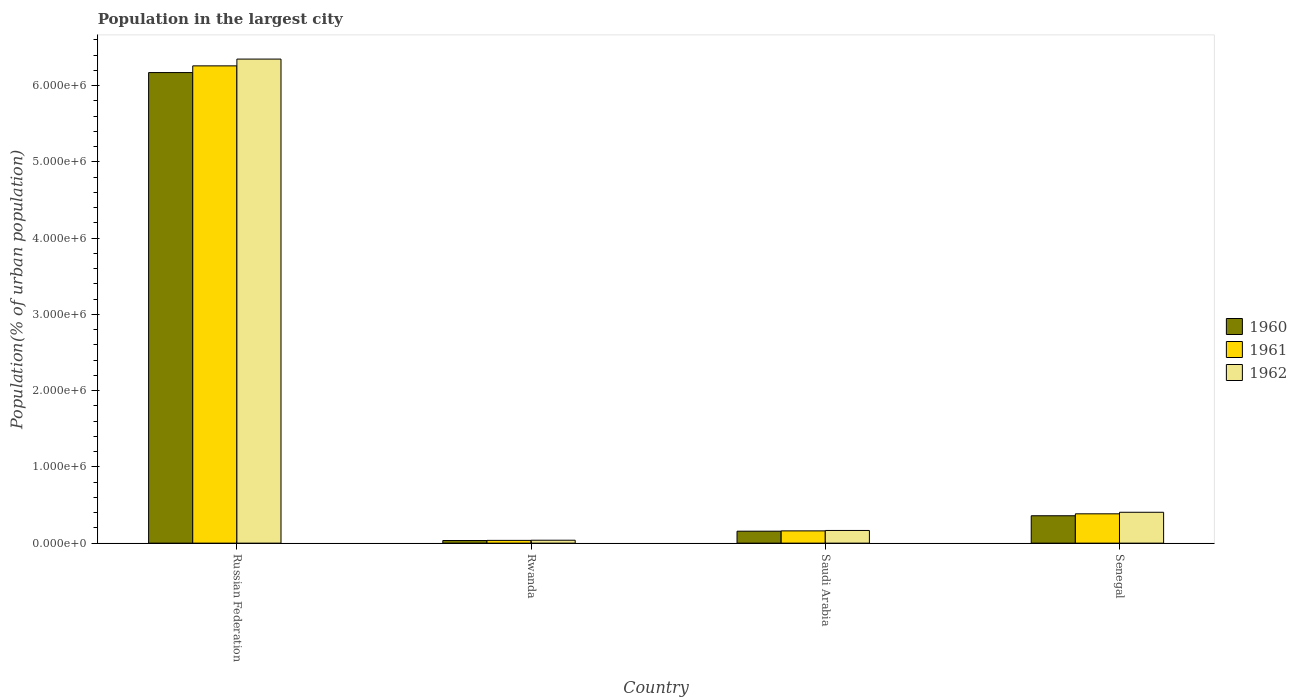How many groups of bars are there?
Offer a very short reply. 4. Are the number of bars per tick equal to the number of legend labels?
Give a very brief answer. Yes. What is the label of the 2nd group of bars from the left?
Keep it short and to the point. Rwanda. In how many cases, is the number of bars for a given country not equal to the number of legend labels?
Provide a short and direct response. 0. What is the population in the largest city in 1962 in Senegal?
Ensure brevity in your answer.  4.05e+05. Across all countries, what is the maximum population in the largest city in 1962?
Offer a very short reply. 6.35e+06. Across all countries, what is the minimum population in the largest city in 1960?
Provide a succinct answer. 3.43e+04. In which country was the population in the largest city in 1962 maximum?
Make the answer very short. Russian Federation. In which country was the population in the largest city in 1961 minimum?
Provide a succinct answer. Rwanda. What is the total population in the largest city in 1962 in the graph?
Provide a succinct answer. 6.96e+06. What is the difference between the population in the largest city in 1962 in Russian Federation and that in Senegal?
Offer a terse response. 5.94e+06. What is the difference between the population in the largest city in 1960 in Russian Federation and the population in the largest city in 1962 in Senegal?
Your answer should be very brief. 5.77e+06. What is the average population in the largest city in 1961 per country?
Give a very brief answer. 1.71e+06. What is the difference between the population in the largest city of/in 1960 and population in the largest city of/in 1962 in Russian Federation?
Keep it short and to the point. -1.77e+05. What is the ratio of the population in the largest city in 1961 in Saudi Arabia to that in Senegal?
Give a very brief answer. 0.42. Is the difference between the population in the largest city in 1960 in Rwanda and Senegal greater than the difference between the population in the largest city in 1962 in Rwanda and Senegal?
Provide a succinct answer. Yes. What is the difference between the highest and the second highest population in the largest city in 1962?
Provide a succinct answer. 5.94e+06. What is the difference between the highest and the lowest population in the largest city in 1961?
Offer a very short reply. 6.22e+06. What does the 1st bar from the left in Russian Federation represents?
Keep it short and to the point. 1960. Are all the bars in the graph horizontal?
Your response must be concise. No. What is the difference between two consecutive major ticks on the Y-axis?
Your answer should be compact. 1.00e+06. Does the graph contain any zero values?
Offer a very short reply. No. Does the graph contain grids?
Your answer should be compact. No. How many legend labels are there?
Make the answer very short. 3. What is the title of the graph?
Your answer should be very brief. Population in the largest city. Does "1978" appear as one of the legend labels in the graph?
Offer a very short reply. No. What is the label or title of the X-axis?
Provide a short and direct response. Country. What is the label or title of the Y-axis?
Provide a short and direct response. Population(% of urban population). What is the Population(% of urban population) of 1960 in Russian Federation?
Provide a succinct answer. 6.17e+06. What is the Population(% of urban population) of 1961 in Russian Federation?
Keep it short and to the point. 6.26e+06. What is the Population(% of urban population) of 1962 in Russian Federation?
Provide a short and direct response. 6.35e+06. What is the Population(% of urban population) in 1960 in Rwanda?
Ensure brevity in your answer.  3.43e+04. What is the Population(% of urban population) of 1961 in Rwanda?
Ensure brevity in your answer.  3.63e+04. What is the Population(% of urban population) in 1962 in Rwanda?
Keep it short and to the point. 3.83e+04. What is the Population(% of urban population) in 1960 in Saudi Arabia?
Make the answer very short. 1.57e+05. What is the Population(% of urban population) of 1961 in Saudi Arabia?
Provide a short and direct response. 1.61e+05. What is the Population(% of urban population) in 1962 in Saudi Arabia?
Offer a very short reply. 1.66e+05. What is the Population(% of urban population) in 1960 in Senegal?
Your answer should be very brief. 3.59e+05. What is the Population(% of urban population) in 1961 in Senegal?
Make the answer very short. 3.84e+05. What is the Population(% of urban population) of 1962 in Senegal?
Your response must be concise. 4.05e+05. Across all countries, what is the maximum Population(% of urban population) in 1960?
Provide a short and direct response. 6.17e+06. Across all countries, what is the maximum Population(% of urban population) in 1961?
Ensure brevity in your answer.  6.26e+06. Across all countries, what is the maximum Population(% of urban population) in 1962?
Your response must be concise. 6.35e+06. Across all countries, what is the minimum Population(% of urban population) in 1960?
Ensure brevity in your answer.  3.43e+04. Across all countries, what is the minimum Population(% of urban population) in 1961?
Provide a short and direct response. 3.63e+04. Across all countries, what is the minimum Population(% of urban population) in 1962?
Your answer should be compact. 3.83e+04. What is the total Population(% of urban population) of 1960 in the graph?
Keep it short and to the point. 6.72e+06. What is the total Population(% of urban population) of 1961 in the graph?
Offer a terse response. 6.84e+06. What is the total Population(% of urban population) in 1962 in the graph?
Provide a succinct answer. 6.96e+06. What is the difference between the Population(% of urban population) in 1960 in Russian Federation and that in Rwanda?
Offer a terse response. 6.14e+06. What is the difference between the Population(% of urban population) in 1961 in Russian Federation and that in Rwanda?
Give a very brief answer. 6.22e+06. What is the difference between the Population(% of urban population) of 1962 in Russian Federation and that in Rwanda?
Your answer should be very brief. 6.31e+06. What is the difference between the Population(% of urban population) of 1960 in Russian Federation and that in Saudi Arabia?
Your answer should be very brief. 6.01e+06. What is the difference between the Population(% of urban population) of 1961 in Russian Federation and that in Saudi Arabia?
Your answer should be compact. 6.10e+06. What is the difference between the Population(% of urban population) in 1962 in Russian Federation and that in Saudi Arabia?
Provide a short and direct response. 6.18e+06. What is the difference between the Population(% of urban population) in 1960 in Russian Federation and that in Senegal?
Offer a terse response. 5.81e+06. What is the difference between the Population(% of urban population) in 1961 in Russian Federation and that in Senegal?
Provide a succinct answer. 5.87e+06. What is the difference between the Population(% of urban population) in 1962 in Russian Federation and that in Senegal?
Your answer should be very brief. 5.94e+06. What is the difference between the Population(% of urban population) in 1960 in Rwanda and that in Saudi Arabia?
Ensure brevity in your answer.  -1.22e+05. What is the difference between the Population(% of urban population) in 1961 in Rwanda and that in Saudi Arabia?
Make the answer very short. -1.25e+05. What is the difference between the Population(% of urban population) of 1962 in Rwanda and that in Saudi Arabia?
Provide a short and direct response. -1.28e+05. What is the difference between the Population(% of urban population) of 1960 in Rwanda and that in Senegal?
Offer a very short reply. -3.25e+05. What is the difference between the Population(% of urban population) in 1961 in Rwanda and that in Senegal?
Ensure brevity in your answer.  -3.48e+05. What is the difference between the Population(% of urban population) of 1962 in Rwanda and that in Senegal?
Make the answer very short. -3.66e+05. What is the difference between the Population(% of urban population) in 1960 in Saudi Arabia and that in Senegal?
Provide a short and direct response. -2.02e+05. What is the difference between the Population(% of urban population) of 1961 in Saudi Arabia and that in Senegal?
Offer a terse response. -2.24e+05. What is the difference between the Population(% of urban population) in 1962 in Saudi Arabia and that in Senegal?
Offer a terse response. -2.38e+05. What is the difference between the Population(% of urban population) in 1960 in Russian Federation and the Population(% of urban population) in 1961 in Rwanda?
Make the answer very short. 6.13e+06. What is the difference between the Population(% of urban population) in 1960 in Russian Federation and the Population(% of urban population) in 1962 in Rwanda?
Your answer should be very brief. 6.13e+06. What is the difference between the Population(% of urban population) in 1961 in Russian Federation and the Population(% of urban population) in 1962 in Rwanda?
Provide a short and direct response. 6.22e+06. What is the difference between the Population(% of urban population) of 1960 in Russian Federation and the Population(% of urban population) of 1961 in Saudi Arabia?
Provide a short and direct response. 6.01e+06. What is the difference between the Population(% of urban population) in 1960 in Russian Federation and the Population(% of urban population) in 1962 in Saudi Arabia?
Keep it short and to the point. 6.00e+06. What is the difference between the Population(% of urban population) in 1961 in Russian Federation and the Population(% of urban population) in 1962 in Saudi Arabia?
Your answer should be very brief. 6.09e+06. What is the difference between the Population(% of urban population) in 1960 in Russian Federation and the Population(% of urban population) in 1961 in Senegal?
Your response must be concise. 5.79e+06. What is the difference between the Population(% of urban population) of 1960 in Russian Federation and the Population(% of urban population) of 1962 in Senegal?
Offer a very short reply. 5.77e+06. What is the difference between the Population(% of urban population) of 1961 in Russian Federation and the Population(% of urban population) of 1962 in Senegal?
Make the answer very short. 5.85e+06. What is the difference between the Population(% of urban population) in 1960 in Rwanda and the Population(% of urban population) in 1961 in Saudi Arabia?
Keep it short and to the point. -1.27e+05. What is the difference between the Population(% of urban population) of 1960 in Rwanda and the Population(% of urban population) of 1962 in Saudi Arabia?
Your answer should be compact. -1.32e+05. What is the difference between the Population(% of urban population) in 1961 in Rwanda and the Population(% of urban population) in 1962 in Saudi Arabia?
Provide a succinct answer. -1.30e+05. What is the difference between the Population(% of urban population) in 1960 in Rwanda and the Population(% of urban population) in 1961 in Senegal?
Keep it short and to the point. -3.50e+05. What is the difference between the Population(% of urban population) in 1960 in Rwanda and the Population(% of urban population) in 1962 in Senegal?
Your response must be concise. -3.70e+05. What is the difference between the Population(% of urban population) of 1961 in Rwanda and the Population(% of urban population) of 1962 in Senegal?
Keep it short and to the point. -3.69e+05. What is the difference between the Population(% of urban population) of 1960 in Saudi Arabia and the Population(% of urban population) of 1961 in Senegal?
Provide a succinct answer. -2.28e+05. What is the difference between the Population(% of urban population) of 1960 in Saudi Arabia and the Population(% of urban population) of 1962 in Senegal?
Give a very brief answer. -2.48e+05. What is the difference between the Population(% of urban population) in 1961 in Saudi Arabia and the Population(% of urban population) in 1962 in Senegal?
Keep it short and to the point. -2.44e+05. What is the average Population(% of urban population) of 1960 per country?
Provide a short and direct response. 1.68e+06. What is the average Population(% of urban population) of 1961 per country?
Offer a terse response. 1.71e+06. What is the average Population(% of urban population) of 1962 per country?
Your answer should be compact. 1.74e+06. What is the difference between the Population(% of urban population) of 1960 and Population(% of urban population) of 1961 in Russian Federation?
Your response must be concise. -8.77e+04. What is the difference between the Population(% of urban population) of 1960 and Population(% of urban population) of 1962 in Russian Federation?
Offer a very short reply. -1.77e+05. What is the difference between the Population(% of urban population) in 1961 and Population(% of urban population) in 1962 in Russian Federation?
Keep it short and to the point. -8.91e+04. What is the difference between the Population(% of urban population) of 1960 and Population(% of urban population) of 1961 in Rwanda?
Your answer should be very brief. -1932. What is the difference between the Population(% of urban population) of 1960 and Population(% of urban population) of 1962 in Rwanda?
Keep it short and to the point. -3976. What is the difference between the Population(% of urban population) of 1961 and Population(% of urban population) of 1962 in Rwanda?
Give a very brief answer. -2044. What is the difference between the Population(% of urban population) of 1960 and Population(% of urban population) of 1961 in Saudi Arabia?
Offer a very short reply. -4157. What is the difference between the Population(% of urban population) in 1960 and Population(% of urban population) in 1962 in Saudi Arabia?
Offer a very short reply. -9658. What is the difference between the Population(% of urban population) of 1961 and Population(% of urban population) of 1962 in Saudi Arabia?
Offer a very short reply. -5501. What is the difference between the Population(% of urban population) in 1960 and Population(% of urban population) in 1961 in Senegal?
Your answer should be compact. -2.53e+04. What is the difference between the Population(% of urban population) of 1960 and Population(% of urban population) of 1962 in Senegal?
Provide a short and direct response. -4.57e+04. What is the difference between the Population(% of urban population) of 1961 and Population(% of urban population) of 1962 in Senegal?
Your response must be concise. -2.04e+04. What is the ratio of the Population(% of urban population) of 1960 in Russian Federation to that in Rwanda?
Give a very brief answer. 179.78. What is the ratio of the Population(% of urban population) in 1961 in Russian Federation to that in Rwanda?
Your answer should be compact. 172.62. What is the ratio of the Population(% of urban population) of 1962 in Russian Federation to that in Rwanda?
Provide a succinct answer. 165.73. What is the ratio of the Population(% of urban population) of 1960 in Russian Federation to that in Saudi Arabia?
Your answer should be very brief. 39.37. What is the ratio of the Population(% of urban population) of 1961 in Russian Federation to that in Saudi Arabia?
Offer a terse response. 38.9. What is the ratio of the Population(% of urban population) of 1962 in Russian Federation to that in Saudi Arabia?
Offer a very short reply. 38.15. What is the ratio of the Population(% of urban population) of 1960 in Russian Federation to that in Senegal?
Give a very brief answer. 17.18. What is the ratio of the Population(% of urban population) of 1961 in Russian Federation to that in Senegal?
Keep it short and to the point. 16.28. What is the ratio of the Population(% of urban population) of 1962 in Russian Federation to that in Senegal?
Your answer should be compact. 15.68. What is the ratio of the Population(% of urban population) of 1960 in Rwanda to that in Saudi Arabia?
Your response must be concise. 0.22. What is the ratio of the Population(% of urban population) of 1961 in Rwanda to that in Saudi Arabia?
Give a very brief answer. 0.23. What is the ratio of the Population(% of urban population) in 1962 in Rwanda to that in Saudi Arabia?
Offer a very short reply. 0.23. What is the ratio of the Population(% of urban population) in 1960 in Rwanda to that in Senegal?
Keep it short and to the point. 0.1. What is the ratio of the Population(% of urban population) of 1961 in Rwanda to that in Senegal?
Your answer should be compact. 0.09. What is the ratio of the Population(% of urban population) of 1962 in Rwanda to that in Senegal?
Your answer should be very brief. 0.09. What is the ratio of the Population(% of urban population) of 1960 in Saudi Arabia to that in Senegal?
Offer a very short reply. 0.44. What is the ratio of the Population(% of urban population) of 1961 in Saudi Arabia to that in Senegal?
Provide a succinct answer. 0.42. What is the ratio of the Population(% of urban population) of 1962 in Saudi Arabia to that in Senegal?
Offer a terse response. 0.41. What is the difference between the highest and the second highest Population(% of urban population) in 1960?
Your answer should be very brief. 5.81e+06. What is the difference between the highest and the second highest Population(% of urban population) in 1961?
Provide a succinct answer. 5.87e+06. What is the difference between the highest and the second highest Population(% of urban population) of 1962?
Ensure brevity in your answer.  5.94e+06. What is the difference between the highest and the lowest Population(% of urban population) of 1960?
Your answer should be very brief. 6.14e+06. What is the difference between the highest and the lowest Population(% of urban population) of 1961?
Provide a succinct answer. 6.22e+06. What is the difference between the highest and the lowest Population(% of urban population) of 1962?
Make the answer very short. 6.31e+06. 